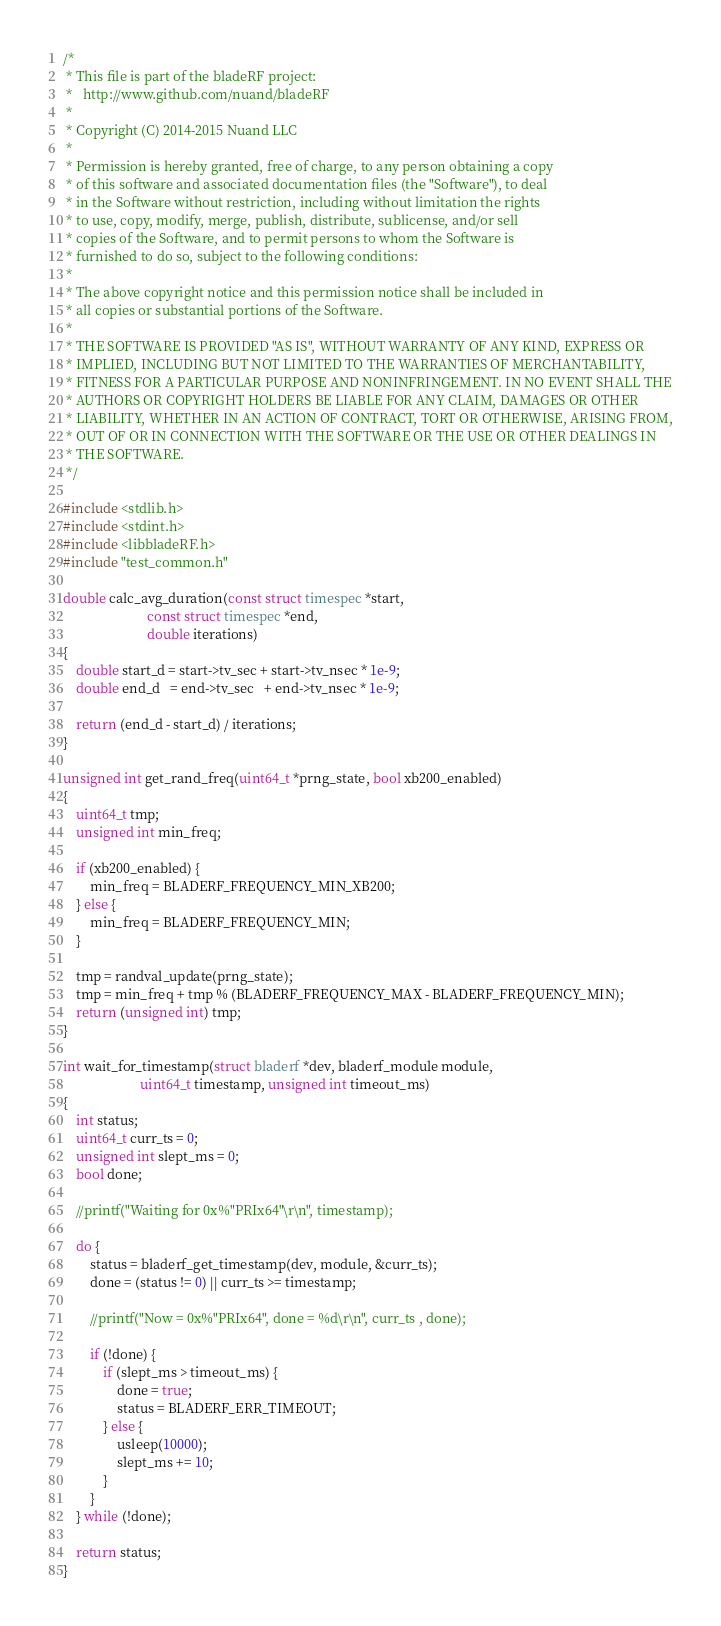Convert code to text. <code><loc_0><loc_0><loc_500><loc_500><_C_>/*
 * This file is part of the bladeRF project:
 *   http://www.github.com/nuand/bladeRF
 *
 * Copyright (C) 2014-2015 Nuand LLC
 *
 * Permission is hereby granted, free of charge, to any person obtaining a copy
 * of this software and associated documentation files (the "Software"), to deal
 * in the Software without restriction, including without limitation the rights
 * to use, copy, modify, merge, publish, distribute, sublicense, and/or sell
 * copies of the Software, and to permit persons to whom the Software is
 * furnished to do so, subject to the following conditions:
 *
 * The above copyright notice and this permission notice shall be included in
 * all copies or substantial portions of the Software.
 *
 * THE SOFTWARE IS PROVIDED "AS IS", WITHOUT WARRANTY OF ANY KIND, EXPRESS OR
 * IMPLIED, INCLUDING BUT NOT LIMITED TO THE WARRANTIES OF MERCHANTABILITY,
 * FITNESS FOR A PARTICULAR PURPOSE AND NONINFRINGEMENT. IN NO EVENT SHALL THE
 * AUTHORS OR COPYRIGHT HOLDERS BE LIABLE FOR ANY CLAIM, DAMAGES OR OTHER
 * LIABILITY, WHETHER IN AN ACTION OF CONTRACT, TORT OR OTHERWISE, ARISING FROM,
 * OUT OF OR IN CONNECTION WITH THE SOFTWARE OR THE USE OR OTHER DEALINGS IN
 * THE SOFTWARE.
 */

#include <stdlib.h>
#include <stdint.h>
#include <libbladeRF.h>
#include "test_common.h"

double calc_avg_duration(const struct timespec *start,
                         const struct timespec *end,
                         double iterations)
{
    double start_d = start->tv_sec + start->tv_nsec * 1e-9;
    double end_d   = end->tv_sec   + end->tv_nsec * 1e-9;

    return (end_d - start_d) / iterations;
}

unsigned int get_rand_freq(uint64_t *prng_state, bool xb200_enabled)
{
    uint64_t tmp;
    unsigned int min_freq;

    if (xb200_enabled) {
        min_freq = BLADERF_FREQUENCY_MIN_XB200;
    } else {
        min_freq = BLADERF_FREQUENCY_MIN;
    }

    tmp = randval_update(prng_state);
    tmp = min_freq + tmp % (BLADERF_FREQUENCY_MAX - BLADERF_FREQUENCY_MIN);
    return (unsigned int) tmp;
}

int wait_for_timestamp(struct bladerf *dev, bladerf_module module,
                       uint64_t timestamp, unsigned int timeout_ms)
{
    int status;
    uint64_t curr_ts = 0;
    unsigned int slept_ms = 0;
    bool done;

    //printf("Waiting for 0x%"PRIx64"\r\n", timestamp);

    do {
        status = bladerf_get_timestamp(dev, module, &curr_ts);
        done = (status != 0) || curr_ts >= timestamp;

        //printf("Now = 0x%"PRIx64", done = %d\r\n", curr_ts , done);

        if (!done) {
            if (slept_ms > timeout_ms) {
                done = true;
                status = BLADERF_ERR_TIMEOUT;
            } else {
                usleep(10000);
                slept_ms += 10;
            }
        }
    } while (!done);

    return status;
}
</code> 